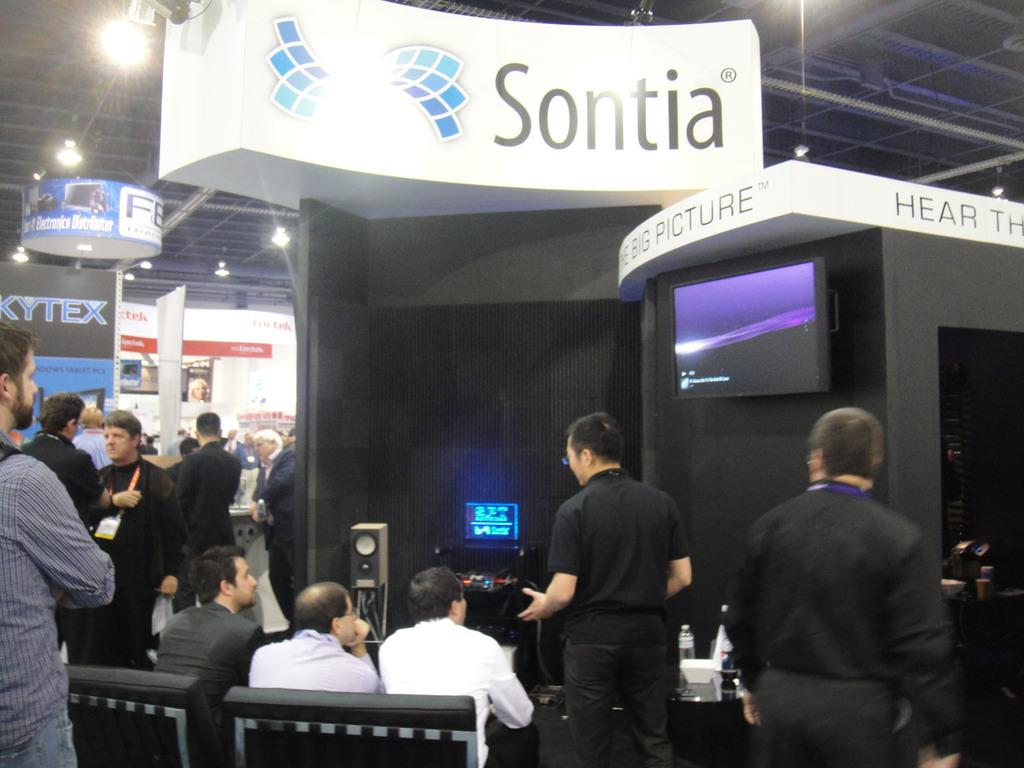What is the main subject of the image? The main subject of the image is a group of people. What can be seen in the background of the image? In the background of the image, there are name boards, lights, and a roof. What type of needle is being used by the people in the image? There is no needle present in the image; it features a group of people and background elements. What kind of lunch is being served to the people in the image? There is no lunch present in the image; it only shows a group of people and background elements. 